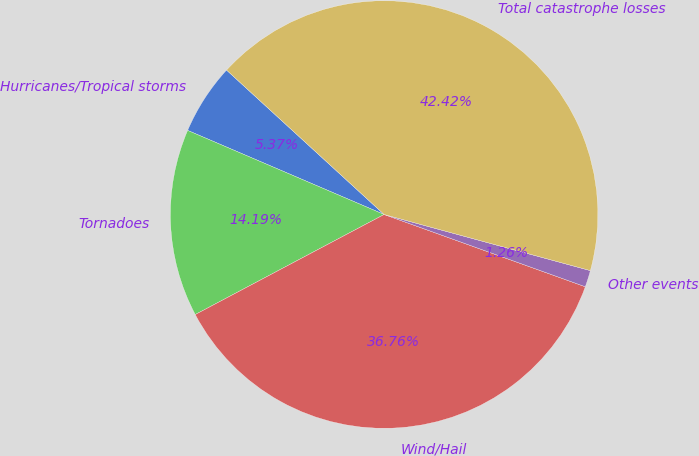<chart> <loc_0><loc_0><loc_500><loc_500><pie_chart><fcel>Hurricanes/Tropical storms<fcel>Tornadoes<fcel>Wind/Hail<fcel>Other events<fcel>Total catastrophe losses<nl><fcel>5.37%<fcel>14.19%<fcel>36.76%<fcel>1.26%<fcel>42.42%<nl></chart> 